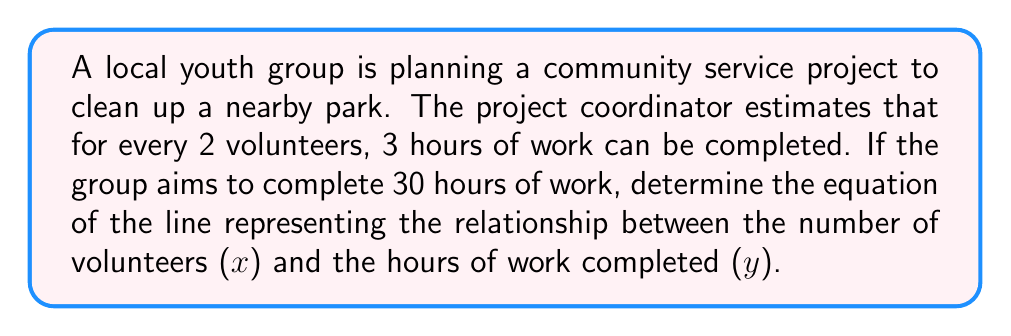Can you answer this question? Let's approach this step-by-step:

1) First, we need to identify two points on the line:
   - With 0 volunteers, 0 hours of work are completed: (0, 0)
   - With 2 volunteers, 3 hours of work are completed: (2, 3)

2) We can use the point-slope form of a line: $y - y_1 = m(x - x_1)$

3) To find the slope (m), we use the formula:
   $m = \frac{y_2 - y_1}{x_2 - x_1} = \frac{3 - 0}{2 - 0} = \frac{3}{2}$

4) Now we can use either point to create our equation. Let's use (0, 0):
   $y - 0 = \frac{3}{2}(x - 0)$

5) Simplify:
   $y = \frac{3}{2}x$

6) This is our final equation, but we can verify it satisfies our goal of 30 hours:
   $30 = \frac{3}{2}x$
   $x = 20$

   So, 20 volunteers would complete 30 hours of work, which aligns with our original ratio of 2 volunteers for 3 hours.
Answer: $y = \frac{3}{2}x$ 